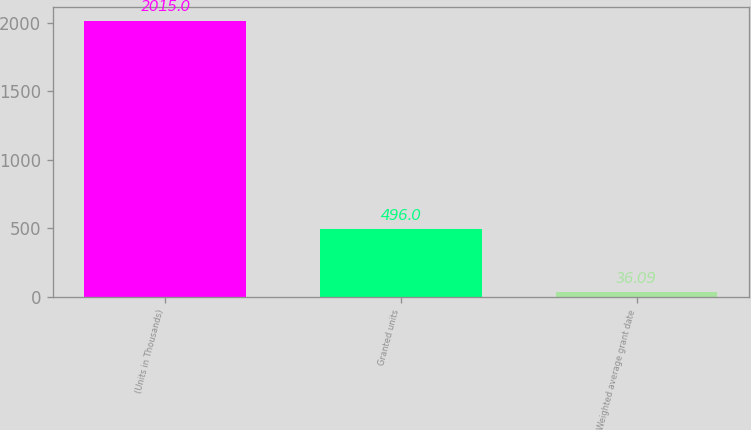<chart> <loc_0><loc_0><loc_500><loc_500><bar_chart><fcel>(Units in Thousands)<fcel>Granted units<fcel>Weighted average grant date<nl><fcel>2015<fcel>496<fcel>36.09<nl></chart> 